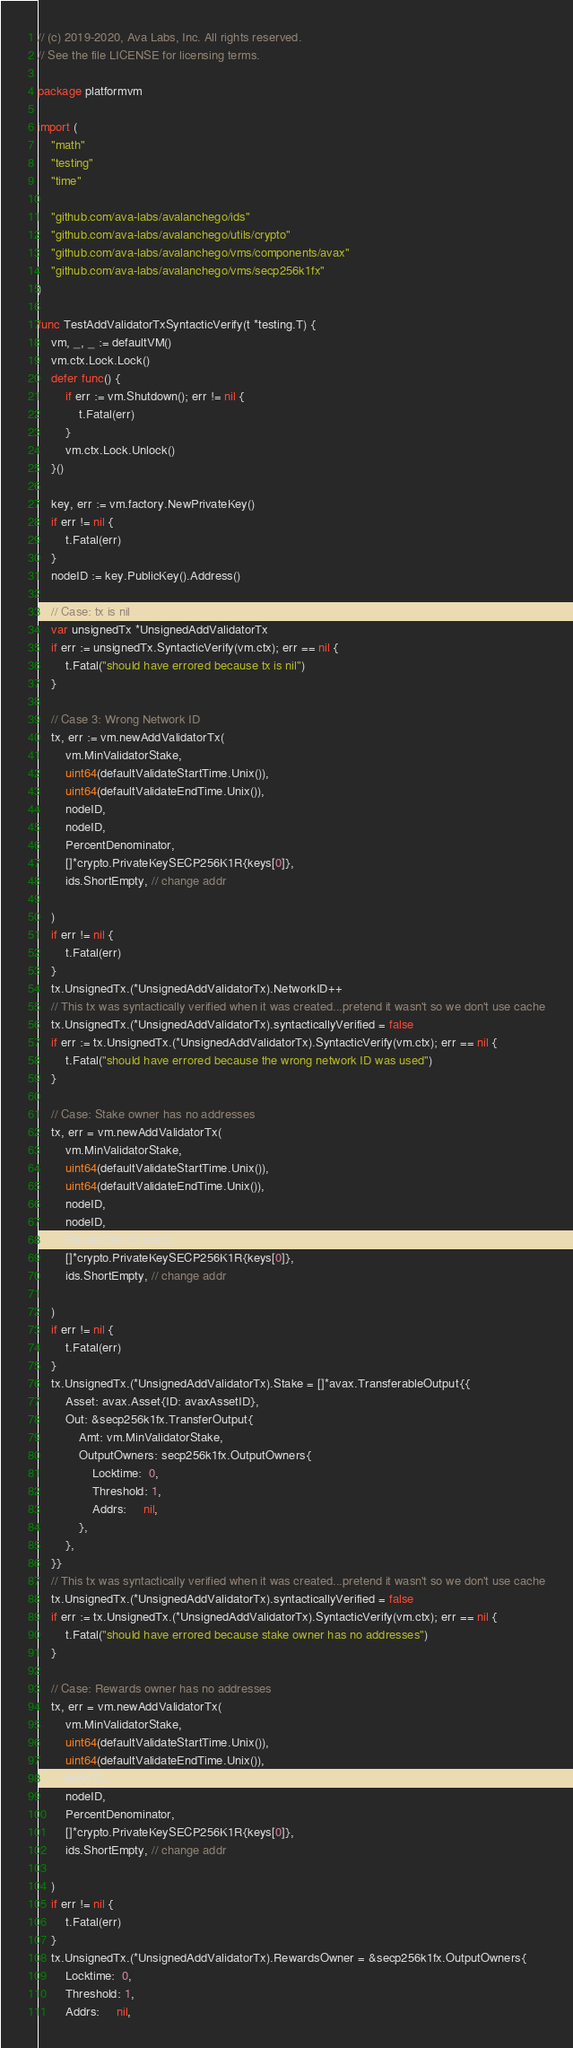<code> <loc_0><loc_0><loc_500><loc_500><_Go_>// (c) 2019-2020, Ava Labs, Inc. All rights reserved.
// See the file LICENSE for licensing terms.

package platformvm

import (
	"math"
	"testing"
	"time"

	"github.com/ava-labs/avalanchego/ids"
	"github.com/ava-labs/avalanchego/utils/crypto"
	"github.com/ava-labs/avalanchego/vms/components/avax"
	"github.com/ava-labs/avalanchego/vms/secp256k1fx"
)

func TestAddValidatorTxSyntacticVerify(t *testing.T) {
	vm, _, _ := defaultVM()
	vm.ctx.Lock.Lock()
	defer func() {
		if err := vm.Shutdown(); err != nil {
			t.Fatal(err)
		}
		vm.ctx.Lock.Unlock()
	}()

	key, err := vm.factory.NewPrivateKey()
	if err != nil {
		t.Fatal(err)
	}
	nodeID := key.PublicKey().Address()

	// Case: tx is nil
	var unsignedTx *UnsignedAddValidatorTx
	if err := unsignedTx.SyntacticVerify(vm.ctx); err == nil {
		t.Fatal("should have errored because tx is nil")
	}

	// Case 3: Wrong Network ID
	tx, err := vm.newAddValidatorTx(
		vm.MinValidatorStake,
		uint64(defaultValidateStartTime.Unix()),
		uint64(defaultValidateEndTime.Unix()),
		nodeID,
		nodeID,
		PercentDenominator,
		[]*crypto.PrivateKeySECP256K1R{keys[0]},
		ids.ShortEmpty, // change addr

	)
	if err != nil {
		t.Fatal(err)
	}
	tx.UnsignedTx.(*UnsignedAddValidatorTx).NetworkID++
	// This tx was syntactically verified when it was created...pretend it wasn't so we don't use cache
	tx.UnsignedTx.(*UnsignedAddValidatorTx).syntacticallyVerified = false
	if err := tx.UnsignedTx.(*UnsignedAddValidatorTx).SyntacticVerify(vm.ctx); err == nil {
		t.Fatal("should have errored because the wrong network ID was used")
	}

	// Case: Stake owner has no addresses
	tx, err = vm.newAddValidatorTx(
		vm.MinValidatorStake,
		uint64(defaultValidateStartTime.Unix()),
		uint64(defaultValidateEndTime.Unix()),
		nodeID,
		nodeID,
		PercentDenominator,
		[]*crypto.PrivateKeySECP256K1R{keys[0]},
		ids.ShortEmpty, // change addr

	)
	if err != nil {
		t.Fatal(err)
	}
	tx.UnsignedTx.(*UnsignedAddValidatorTx).Stake = []*avax.TransferableOutput{{
		Asset: avax.Asset{ID: avaxAssetID},
		Out: &secp256k1fx.TransferOutput{
			Amt: vm.MinValidatorStake,
			OutputOwners: secp256k1fx.OutputOwners{
				Locktime:  0,
				Threshold: 1,
				Addrs:     nil,
			},
		},
	}}
	// This tx was syntactically verified when it was created...pretend it wasn't so we don't use cache
	tx.UnsignedTx.(*UnsignedAddValidatorTx).syntacticallyVerified = false
	if err := tx.UnsignedTx.(*UnsignedAddValidatorTx).SyntacticVerify(vm.ctx); err == nil {
		t.Fatal("should have errored because stake owner has no addresses")
	}

	// Case: Rewards owner has no addresses
	tx, err = vm.newAddValidatorTx(
		vm.MinValidatorStake,
		uint64(defaultValidateStartTime.Unix()),
		uint64(defaultValidateEndTime.Unix()),
		nodeID,
		nodeID,
		PercentDenominator,
		[]*crypto.PrivateKeySECP256K1R{keys[0]},
		ids.ShortEmpty, // change addr

	)
	if err != nil {
		t.Fatal(err)
	}
	tx.UnsignedTx.(*UnsignedAddValidatorTx).RewardsOwner = &secp256k1fx.OutputOwners{
		Locktime:  0,
		Threshold: 1,
		Addrs:     nil,</code> 